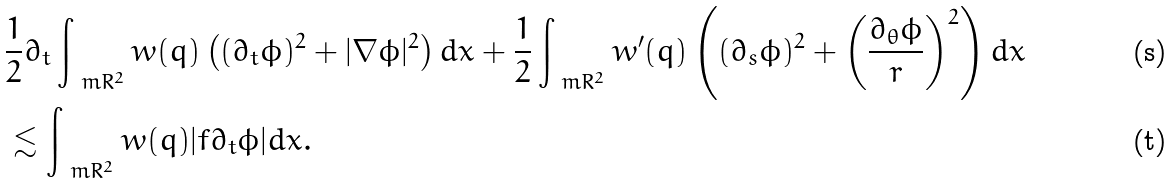<formula> <loc_0><loc_0><loc_500><loc_500>& \frac { 1 } { 2 } \partial _ { t } \int _ { \ m R ^ { 2 } } w ( q ) \left ( ( \partial _ { t } \phi ) ^ { 2 } + | \nabla \phi | ^ { 2 } \right ) d x + \frac { 1 } { 2 } \int _ { \ m R ^ { 2 } } w ^ { \prime } ( q ) \left ( ( \partial _ { s } \phi ) ^ { 2 } + \left ( \frac { \partial _ { \theta } \phi } { r } \right ) ^ { 2 } \right ) d x \\ & \lesssim \int _ { \ m R ^ { 2 } } w ( q ) | f \partial _ { t } \phi | d x .</formula> 